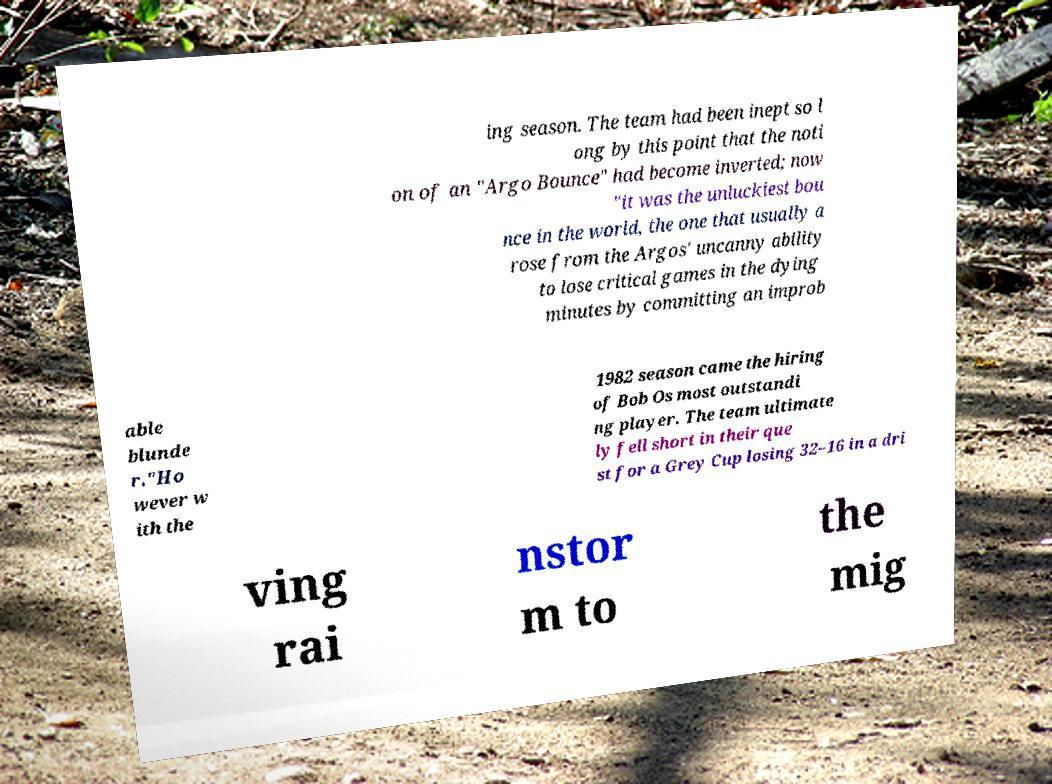Can you read and provide the text displayed in the image?This photo seems to have some interesting text. Can you extract and type it out for me? ing season. The team had been inept so l ong by this point that the noti on of an "Argo Bounce" had become inverted; now "it was the unluckiest bou nce in the world, the one that usually a rose from the Argos' uncanny ability to lose critical games in the dying minutes by committing an improb able blunde r."Ho wever w ith the 1982 season came the hiring of Bob Os most outstandi ng player. The team ultimate ly fell short in their que st for a Grey Cup losing 32–16 in a dri ving rai nstor m to the mig 